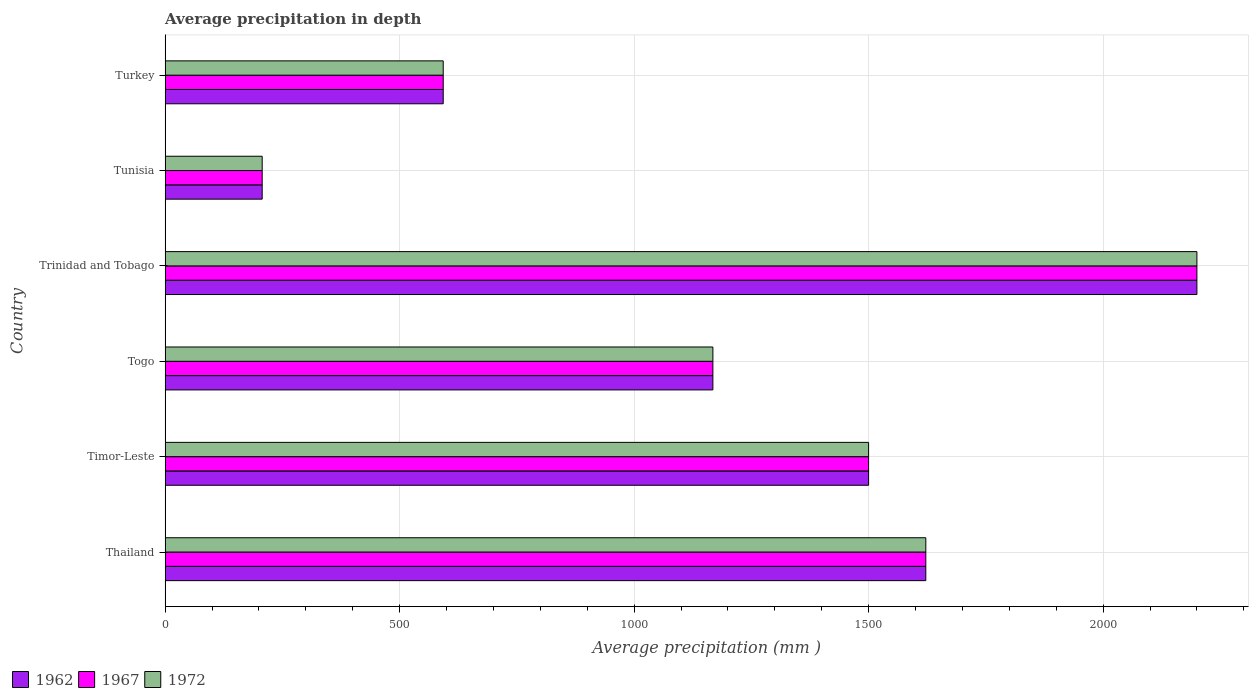How many different coloured bars are there?
Make the answer very short. 3. Are the number of bars on each tick of the Y-axis equal?
Your response must be concise. Yes. How many bars are there on the 5th tick from the top?
Keep it short and to the point. 3. What is the label of the 5th group of bars from the top?
Provide a short and direct response. Timor-Leste. In how many cases, is the number of bars for a given country not equal to the number of legend labels?
Ensure brevity in your answer.  0. What is the average precipitation in 1967 in Thailand?
Make the answer very short. 1622. Across all countries, what is the maximum average precipitation in 1972?
Offer a terse response. 2200. Across all countries, what is the minimum average precipitation in 1972?
Keep it short and to the point. 207. In which country was the average precipitation in 1962 maximum?
Offer a terse response. Trinidad and Tobago. In which country was the average precipitation in 1972 minimum?
Offer a very short reply. Tunisia. What is the total average precipitation in 1967 in the graph?
Your answer should be compact. 7290. What is the difference between the average precipitation in 1967 in Timor-Leste and that in Trinidad and Tobago?
Provide a succinct answer. -700. What is the difference between the average precipitation in 1972 in Thailand and the average precipitation in 1962 in Turkey?
Provide a succinct answer. 1029. What is the average average precipitation in 1967 per country?
Your response must be concise. 1215. What is the difference between the average precipitation in 1967 and average precipitation in 1972 in Togo?
Ensure brevity in your answer.  0. What is the ratio of the average precipitation in 1972 in Timor-Leste to that in Turkey?
Offer a very short reply. 2.53. Is the average precipitation in 1962 in Thailand less than that in Tunisia?
Give a very brief answer. No. Is the difference between the average precipitation in 1967 in Thailand and Trinidad and Tobago greater than the difference between the average precipitation in 1972 in Thailand and Trinidad and Tobago?
Ensure brevity in your answer.  No. What is the difference between the highest and the second highest average precipitation in 1967?
Your answer should be compact. 578. What is the difference between the highest and the lowest average precipitation in 1967?
Your answer should be very brief. 1993. What does the 3rd bar from the bottom in Thailand represents?
Your response must be concise. 1972. Is it the case that in every country, the sum of the average precipitation in 1962 and average precipitation in 1967 is greater than the average precipitation in 1972?
Provide a succinct answer. Yes. How many bars are there?
Your answer should be very brief. 18. Are all the bars in the graph horizontal?
Keep it short and to the point. Yes. What is the difference between two consecutive major ticks on the X-axis?
Offer a terse response. 500. Where does the legend appear in the graph?
Ensure brevity in your answer.  Bottom left. How many legend labels are there?
Make the answer very short. 3. What is the title of the graph?
Give a very brief answer. Average precipitation in depth. Does "1998" appear as one of the legend labels in the graph?
Your response must be concise. No. What is the label or title of the X-axis?
Provide a succinct answer. Average precipitation (mm ). What is the Average precipitation (mm ) of 1962 in Thailand?
Offer a terse response. 1622. What is the Average precipitation (mm ) in 1967 in Thailand?
Offer a very short reply. 1622. What is the Average precipitation (mm ) in 1972 in Thailand?
Provide a succinct answer. 1622. What is the Average precipitation (mm ) of 1962 in Timor-Leste?
Provide a succinct answer. 1500. What is the Average precipitation (mm ) in 1967 in Timor-Leste?
Make the answer very short. 1500. What is the Average precipitation (mm ) of 1972 in Timor-Leste?
Your response must be concise. 1500. What is the Average precipitation (mm ) in 1962 in Togo?
Provide a succinct answer. 1168. What is the Average precipitation (mm ) in 1967 in Togo?
Keep it short and to the point. 1168. What is the Average precipitation (mm ) in 1972 in Togo?
Provide a short and direct response. 1168. What is the Average precipitation (mm ) of 1962 in Trinidad and Tobago?
Offer a very short reply. 2200. What is the Average precipitation (mm ) of 1967 in Trinidad and Tobago?
Give a very brief answer. 2200. What is the Average precipitation (mm ) of 1972 in Trinidad and Tobago?
Your response must be concise. 2200. What is the Average precipitation (mm ) in 1962 in Tunisia?
Ensure brevity in your answer.  207. What is the Average precipitation (mm ) of 1967 in Tunisia?
Your answer should be very brief. 207. What is the Average precipitation (mm ) of 1972 in Tunisia?
Your answer should be compact. 207. What is the Average precipitation (mm ) of 1962 in Turkey?
Your response must be concise. 593. What is the Average precipitation (mm ) in 1967 in Turkey?
Ensure brevity in your answer.  593. What is the Average precipitation (mm ) of 1972 in Turkey?
Your answer should be very brief. 593. Across all countries, what is the maximum Average precipitation (mm ) of 1962?
Your answer should be compact. 2200. Across all countries, what is the maximum Average precipitation (mm ) of 1967?
Give a very brief answer. 2200. Across all countries, what is the maximum Average precipitation (mm ) in 1972?
Provide a succinct answer. 2200. Across all countries, what is the minimum Average precipitation (mm ) of 1962?
Provide a succinct answer. 207. Across all countries, what is the minimum Average precipitation (mm ) of 1967?
Your answer should be very brief. 207. Across all countries, what is the minimum Average precipitation (mm ) of 1972?
Provide a succinct answer. 207. What is the total Average precipitation (mm ) in 1962 in the graph?
Offer a terse response. 7290. What is the total Average precipitation (mm ) in 1967 in the graph?
Your response must be concise. 7290. What is the total Average precipitation (mm ) in 1972 in the graph?
Keep it short and to the point. 7290. What is the difference between the Average precipitation (mm ) of 1962 in Thailand and that in Timor-Leste?
Keep it short and to the point. 122. What is the difference between the Average precipitation (mm ) in 1967 in Thailand and that in Timor-Leste?
Your response must be concise. 122. What is the difference between the Average precipitation (mm ) of 1972 in Thailand and that in Timor-Leste?
Provide a short and direct response. 122. What is the difference between the Average precipitation (mm ) of 1962 in Thailand and that in Togo?
Give a very brief answer. 454. What is the difference between the Average precipitation (mm ) of 1967 in Thailand and that in Togo?
Offer a terse response. 454. What is the difference between the Average precipitation (mm ) in 1972 in Thailand and that in Togo?
Offer a terse response. 454. What is the difference between the Average precipitation (mm ) of 1962 in Thailand and that in Trinidad and Tobago?
Keep it short and to the point. -578. What is the difference between the Average precipitation (mm ) in 1967 in Thailand and that in Trinidad and Tobago?
Provide a short and direct response. -578. What is the difference between the Average precipitation (mm ) of 1972 in Thailand and that in Trinidad and Tobago?
Provide a short and direct response. -578. What is the difference between the Average precipitation (mm ) in 1962 in Thailand and that in Tunisia?
Your response must be concise. 1415. What is the difference between the Average precipitation (mm ) of 1967 in Thailand and that in Tunisia?
Offer a very short reply. 1415. What is the difference between the Average precipitation (mm ) of 1972 in Thailand and that in Tunisia?
Provide a succinct answer. 1415. What is the difference between the Average precipitation (mm ) of 1962 in Thailand and that in Turkey?
Make the answer very short. 1029. What is the difference between the Average precipitation (mm ) in 1967 in Thailand and that in Turkey?
Ensure brevity in your answer.  1029. What is the difference between the Average precipitation (mm ) of 1972 in Thailand and that in Turkey?
Your answer should be very brief. 1029. What is the difference between the Average precipitation (mm ) of 1962 in Timor-Leste and that in Togo?
Offer a very short reply. 332. What is the difference between the Average precipitation (mm ) of 1967 in Timor-Leste and that in Togo?
Your response must be concise. 332. What is the difference between the Average precipitation (mm ) in 1972 in Timor-Leste and that in Togo?
Ensure brevity in your answer.  332. What is the difference between the Average precipitation (mm ) in 1962 in Timor-Leste and that in Trinidad and Tobago?
Ensure brevity in your answer.  -700. What is the difference between the Average precipitation (mm ) of 1967 in Timor-Leste and that in Trinidad and Tobago?
Give a very brief answer. -700. What is the difference between the Average precipitation (mm ) of 1972 in Timor-Leste and that in Trinidad and Tobago?
Your answer should be compact. -700. What is the difference between the Average precipitation (mm ) in 1962 in Timor-Leste and that in Tunisia?
Make the answer very short. 1293. What is the difference between the Average precipitation (mm ) in 1967 in Timor-Leste and that in Tunisia?
Your answer should be very brief. 1293. What is the difference between the Average precipitation (mm ) of 1972 in Timor-Leste and that in Tunisia?
Ensure brevity in your answer.  1293. What is the difference between the Average precipitation (mm ) of 1962 in Timor-Leste and that in Turkey?
Provide a short and direct response. 907. What is the difference between the Average precipitation (mm ) in 1967 in Timor-Leste and that in Turkey?
Offer a terse response. 907. What is the difference between the Average precipitation (mm ) in 1972 in Timor-Leste and that in Turkey?
Your response must be concise. 907. What is the difference between the Average precipitation (mm ) of 1962 in Togo and that in Trinidad and Tobago?
Your answer should be compact. -1032. What is the difference between the Average precipitation (mm ) of 1967 in Togo and that in Trinidad and Tobago?
Your response must be concise. -1032. What is the difference between the Average precipitation (mm ) of 1972 in Togo and that in Trinidad and Tobago?
Provide a short and direct response. -1032. What is the difference between the Average precipitation (mm ) in 1962 in Togo and that in Tunisia?
Offer a terse response. 961. What is the difference between the Average precipitation (mm ) in 1967 in Togo and that in Tunisia?
Your answer should be very brief. 961. What is the difference between the Average precipitation (mm ) of 1972 in Togo and that in Tunisia?
Your answer should be compact. 961. What is the difference between the Average precipitation (mm ) of 1962 in Togo and that in Turkey?
Provide a succinct answer. 575. What is the difference between the Average precipitation (mm ) in 1967 in Togo and that in Turkey?
Offer a very short reply. 575. What is the difference between the Average precipitation (mm ) in 1972 in Togo and that in Turkey?
Your response must be concise. 575. What is the difference between the Average precipitation (mm ) of 1962 in Trinidad and Tobago and that in Tunisia?
Keep it short and to the point. 1993. What is the difference between the Average precipitation (mm ) of 1967 in Trinidad and Tobago and that in Tunisia?
Your answer should be compact. 1993. What is the difference between the Average precipitation (mm ) in 1972 in Trinidad and Tobago and that in Tunisia?
Give a very brief answer. 1993. What is the difference between the Average precipitation (mm ) in 1962 in Trinidad and Tobago and that in Turkey?
Offer a very short reply. 1607. What is the difference between the Average precipitation (mm ) of 1967 in Trinidad and Tobago and that in Turkey?
Your answer should be compact. 1607. What is the difference between the Average precipitation (mm ) in 1972 in Trinidad and Tobago and that in Turkey?
Keep it short and to the point. 1607. What is the difference between the Average precipitation (mm ) of 1962 in Tunisia and that in Turkey?
Give a very brief answer. -386. What is the difference between the Average precipitation (mm ) in 1967 in Tunisia and that in Turkey?
Offer a very short reply. -386. What is the difference between the Average precipitation (mm ) in 1972 in Tunisia and that in Turkey?
Provide a short and direct response. -386. What is the difference between the Average precipitation (mm ) in 1962 in Thailand and the Average precipitation (mm ) in 1967 in Timor-Leste?
Give a very brief answer. 122. What is the difference between the Average precipitation (mm ) in 1962 in Thailand and the Average precipitation (mm ) in 1972 in Timor-Leste?
Your answer should be compact. 122. What is the difference between the Average precipitation (mm ) of 1967 in Thailand and the Average precipitation (mm ) of 1972 in Timor-Leste?
Your answer should be very brief. 122. What is the difference between the Average precipitation (mm ) of 1962 in Thailand and the Average precipitation (mm ) of 1967 in Togo?
Your answer should be compact. 454. What is the difference between the Average precipitation (mm ) in 1962 in Thailand and the Average precipitation (mm ) in 1972 in Togo?
Keep it short and to the point. 454. What is the difference between the Average precipitation (mm ) of 1967 in Thailand and the Average precipitation (mm ) of 1972 in Togo?
Make the answer very short. 454. What is the difference between the Average precipitation (mm ) of 1962 in Thailand and the Average precipitation (mm ) of 1967 in Trinidad and Tobago?
Your answer should be compact. -578. What is the difference between the Average precipitation (mm ) in 1962 in Thailand and the Average precipitation (mm ) in 1972 in Trinidad and Tobago?
Keep it short and to the point. -578. What is the difference between the Average precipitation (mm ) of 1967 in Thailand and the Average precipitation (mm ) of 1972 in Trinidad and Tobago?
Provide a short and direct response. -578. What is the difference between the Average precipitation (mm ) in 1962 in Thailand and the Average precipitation (mm ) in 1967 in Tunisia?
Offer a terse response. 1415. What is the difference between the Average precipitation (mm ) in 1962 in Thailand and the Average precipitation (mm ) in 1972 in Tunisia?
Your response must be concise. 1415. What is the difference between the Average precipitation (mm ) of 1967 in Thailand and the Average precipitation (mm ) of 1972 in Tunisia?
Your answer should be very brief. 1415. What is the difference between the Average precipitation (mm ) of 1962 in Thailand and the Average precipitation (mm ) of 1967 in Turkey?
Your response must be concise. 1029. What is the difference between the Average precipitation (mm ) of 1962 in Thailand and the Average precipitation (mm ) of 1972 in Turkey?
Ensure brevity in your answer.  1029. What is the difference between the Average precipitation (mm ) in 1967 in Thailand and the Average precipitation (mm ) in 1972 in Turkey?
Provide a succinct answer. 1029. What is the difference between the Average precipitation (mm ) of 1962 in Timor-Leste and the Average precipitation (mm ) of 1967 in Togo?
Make the answer very short. 332. What is the difference between the Average precipitation (mm ) in 1962 in Timor-Leste and the Average precipitation (mm ) in 1972 in Togo?
Your answer should be very brief. 332. What is the difference between the Average precipitation (mm ) of 1967 in Timor-Leste and the Average precipitation (mm ) of 1972 in Togo?
Keep it short and to the point. 332. What is the difference between the Average precipitation (mm ) of 1962 in Timor-Leste and the Average precipitation (mm ) of 1967 in Trinidad and Tobago?
Offer a terse response. -700. What is the difference between the Average precipitation (mm ) in 1962 in Timor-Leste and the Average precipitation (mm ) in 1972 in Trinidad and Tobago?
Your answer should be very brief. -700. What is the difference between the Average precipitation (mm ) in 1967 in Timor-Leste and the Average precipitation (mm ) in 1972 in Trinidad and Tobago?
Make the answer very short. -700. What is the difference between the Average precipitation (mm ) in 1962 in Timor-Leste and the Average precipitation (mm ) in 1967 in Tunisia?
Provide a short and direct response. 1293. What is the difference between the Average precipitation (mm ) of 1962 in Timor-Leste and the Average precipitation (mm ) of 1972 in Tunisia?
Give a very brief answer. 1293. What is the difference between the Average precipitation (mm ) in 1967 in Timor-Leste and the Average precipitation (mm ) in 1972 in Tunisia?
Keep it short and to the point. 1293. What is the difference between the Average precipitation (mm ) of 1962 in Timor-Leste and the Average precipitation (mm ) of 1967 in Turkey?
Keep it short and to the point. 907. What is the difference between the Average precipitation (mm ) of 1962 in Timor-Leste and the Average precipitation (mm ) of 1972 in Turkey?
Offer a very short reply. 907. What is the difference between the Average precipitation (mm ) of 1967 in Timor-Leste and the Average precipitation (mm ) of 1972 in Turkey?
Make the answer very short. 907. What is the difference between the Average precipitation (mm ) of 1962 in Togo and the Average precipitation (mm ) of 1967 in Trinidad and Tobago?
Your response must be concise. -1032. What is the difference between the Average precipitation (mm ) in 1962 in Togo and the Average precipitation (mm ) in 1972 in Trinidad and Tobago?
Your answer should be compact. -1032. What is the difference between the Average precipitation (mm ) in 1967 in Togo and the Average precipitation (mm ) in 1972 in Trinidad and Tobago?
Offer a very short reply. -1032. What is the difference between the Average precipitation (mm ) in 1962 in Togo and the Average precipitation (mm ) in 1967 in Tunisia?
Make the answer very short. 961. What is the difference between the Average precipitation (mm ) of 1962 in Togo and the Average precipitation (mm ) of 1972 in Tunisia?
Make the answer very short. 961. What is the difference between the Average precipitation (mm ) of 1967 in Togo and the Average precipitation (mm ) of 1972 in Tunisia?
Offer a very short reply. 961. What is the difference between the Average precipitation (mm ) of 1962 in Togo and the Average precipitation (mm ) of 1967 in Turkey?
Your answer should be very brief. 575. What is the difference between the Average precipitation (mm ) of 1962 in Togo and the Average precipitation (mm ) of 1972 in Turkey?
Offer a terse response. 575. What is the difference between the Average precipitation (mm ) in 1967 in Togo and the Average precipitation (mm ) in 1972 in Turkey?
Provide a succinct answer. 575. What is the difference between the Average precipitation (mm ) of 1962 in Trinidad and Tobago and the Average precipitation (mm ) of 1967 in Tunisia?
Keep it short and to the point. 1993. What is the difference between the Average precipitation (mm ) of 1962 in Trinidad and Tobago and the Average precipitation (mm ) of 1972 in Tunisia?
Provide a short and direct response. 1993. What is the difference between the Average precipitation (mm ) of 1967 in Trinidad and Tobago and the Average precipitation (mm ) of 1972 in Tunisia?
Provide a short and direct response. 1993. What is the difference between the Average precipitation (mm ) in 1962 in Trinidad and Tobago and the Average precipitation (mm ) in 1967 in Turkey?
Give a very brief answer. 1607. What is the difference between the Average precipitation (mm ) of 1962 in Trinidad and Tobago and the Average precipitation (mm ) of 1972 in Turkey?
Your answer should be very brief. 1607. What is the difference between the Average precipitation (mm ) of 1967 in Trinidad and Tobago and the Average precipitation (mm ) of 1972 in Turkey?
Your answer should be compact. 1607. What is the difference between the Average precipitation (mm ) in 1962 in Tunisia and the Average precipitation (mm ) in 1967 in Turkey?
Your answer should be very brief. -386. What is the difference between the Average precipitation (mm ) of 1962 in Tunisia and the Average precipitation (mm ) of 1972 in Turkey?
Your answer should be compact. -386. What is the difference between the Average precipitation (mm ) of 1967 in Tunisia and the Average precipitation (mm ) of 1972 in Turkey?
Keep it short and to the point. -386. What is the average Average precipitation (mm ) in 1962 per country?
Make the answer very short. 1215. What is the average Average precipitation (mm ) in 1967 per country?
Your answer should be compact. 1215. What is the average Average precipitation (mm ) in 1972 per country?
Your response must be concise. 1215. What is the difference between the Average precipitation (mm ) of 1962 and Average precipitation (mm ) of 1972 in Thailand?
Ensure brevity in your answer.  0. What is the difference between the Average precipitation (mm ) of 1967 and Average precipitation (mm ) of 1972 in Thailand?
Your answer should be very brief. 0. What is the difference between the Average precipitation (mm ) in 1962 and Average precipitation (mm ) in 1972 in Timor-Leste?
Offer a very short reply. 0. What is the difference between the Average precipitation (mm ) of 1967 and Average precipitation (mm ) of 1972 in Timor-Leste?
Your answer should be very brief. 0. What is the difference between the Average precipitation (mm ) of 1962 and Average precipitation (mm ) of 1967 in Trinidad and Tobago?
Offer a terse response. 0. What is the difference between the Average precipitation (mm ) in 1962 and Average precipitation (mm ) in 1972 in Trinidad and Tobago?
Your answer should be very brief. 0. What is the difference between the Average precipitation (mm ) in 1962 and Average precipitation (mm ) in 1967 in Tunisia?
Provide a succinct answer. 0. What is the difference between the Average precipitation (mm ) in 1967 and Average precipitation (mm ) in 1972 in Tunisia?
Your answer should be compact. 0. What is the difference between the Average precipitation (mm ) of 1962 and Average precipitation (mm ) of 1972 in Turkey?
Keep it short and to the point. 0. What is the ratio of the Average precipitation (mm ) in 1962 in Thailand to that in Timor-Leste?
Keep it short and to the point. 1.08. What is the ratio of the Average precipitation (mm ) of 1967 in Thailand to that in Timor-Leste?
Keep it short and to the point. 1.08. What is the ratio of the Average precipitation (mm ) of 1972 in Thailand to that in Timor-Leste?
Provide a succinct answer. 1.08. What is the ratio of the Average precipitation (mm ) in 1962 in Thailand to that in Togo?
Keep it short and to the point. 1.39. What is the ratio of the Average precipitation (mm ) in 1967 in Thailand to that in Togo?
Your answer should be compact. 1.39. What is the ratio of the Average precipitation (mm ) of 1972 in Thailand to that in Togo?
Make the answer very short. 1.39. What is the ratio of the Average precipitation (mm ) in 1962 in Thailand to that in Trinidad and Tobago?
Your answer should be very brief. 0.74. What is the ratio of the Average precipitation (mm ) of 1967 in Thailand to that in Trinidad and Tobago?
Make the answer very short. 0.74. What is the ratio of the Average precipitation (mm ) of 1972 in Thailand to that in Trinidad and Tobago?
Your response must be concise. 0.74. What is the ratio of the Average precipitation (mm ) in 1962 in Thailand to that in Tunisia?
Your answer should be very brief. 7.84. What is the ratio of the Average precipitation (mm ) of 1967 in Thailand to that in Tunisia?
Ensure brevity in your answer.  7.84. What is the ratio of the Average precipitation (mm ) of 1972 in Thailand to that in Tunisia?
Your response must be concise. 7.84. What is the ratio of the Average precipitation (mm ) in 1962 in Thailand to that in Turkey?
Provide a short and direct response. 2.74. What is the ratio of the Average precipitation (mm ) in 1967 in Thailand to that in Turkey?
Provide a succinct answer. 2.74. What is the ratio of the Average precipitation (mm ) of 1972 in Thailand to that in Turkey?
Offer a very short reply. 2.74. What is the ratio of the Average precipitation (mm ) in 1962 in Timor-Leste to that in Togo?
Provide a short and direct response. 1.28. What is the ratio of the Average precipitation (mm ) in 1967 in Timor-Leste to that in Togo?
Your answer should be compact. 1.28. What is the ratio of the Average precipitation (mm ) of 1972 in Timor-Leste to that in Togo?
Your answer should be very brief. 1.28. What is the ratio of the Average precipitation (mm ) in 1962 in Timor-Leste to that in Trinidad and Tobago?
Make the answer very short. 0.68. What is the ratio of the Average precipitation (mm ) in 1967 in Timor-Leste to that in Trinidad and Tobago?
Your answer should be very brief. 0.68. What is the ratio of the Average precipitation (mm ) in 1972 in Timor-Leste to that in Trinidad and Tobago?
Give a very brief answer. 0.68. What is the ratio of the Average precipitation (mm ) of 1962 in Timor-Leste to that in Tunisia?
Your response must be concise. 7.25. What is the ratio of the Average precipitation (mm ) in 1967 in Timor-Leste to that in Tunisia?
Your answer should be compact. 7.25. What is the ratio of the Average precipitation (mm ) of 1972 in Timor-Leste to that in Tunisia?
Offer a very short reply. 7.25. What is the ratio of the Average precipitation (mm ) of 1962 in Timor-Leste to that in Turkey?
Your answer should be very brief. 2.53. What is the ratio of the Average precipitation (mm ) in 1967 in Timor-Leste to that in Turkey?
Make the answer very short. 2.53. What is the ratio of the Average precipitation (mm ) in 1972 in Timor-Leste to that in Turkey?
Your response must be concise. 2.53. What is the ratio of the Average precipitation (mm ) in 1962 in Togo to that in Trinidad and Tobago?
Provide a short and direct response. 0.53. What is the ratio of the Average precipitation (mm ) of 1967 in Togo to that in Trinidad and Tobago?
Your response must be concise. 0.53. What is the ratio of the Average precipitation (mm ) in 1972 in Togo to that in Trinidad and Tobago?
Provide a succinct answer. 0.53. What is the ratio of the Average precipitation (mm ) of 1962 in Togo to that in Tunisia?
Provide a short and direct response. 5.64. What is the ratio of the Average precipitation (mm ) in 1967 in Togo to that in Tunisia?
Offer a terse response. 5.64. What is the ratio of the Average precipitation (mm ) of 1972 in Togo to that in Tunisia?
Offer a terse response. 5.64. What is the ratio of the Average precipitation (mm ) in 1962 in Togo to that in Turkey?
Your answer should be compact. 1.97. What is the ratio of the Average precipitation (mm ) of 1967 in Togo to that in Turkey?
Your answer should be compact. 1.97. What is the ratio of the Average precipitation (mm ) in 1972 in Togo to that in Turkey?
Give a very brief answer. 1.97. What is the ratio of the Average precipitation (mm ) of 1962 in Trinidad and Tobago to that in Tunisia?
Your answer should be compact. 10.63. What is the ratio of the Average precipitation (mm ) in 1967 in Trinidad and Tobago to that in Tunisia?
Ensure brevity in your answer.  10.63. What is the ratio of the Average precipitation (mm ) of 1972 in Trinidad and Tobago to that in Tunisia?
Your response must be concise. 10.63. What is the ratio of the Average precipitation (mm ) in 1962 in Trinidad and Tobago to that in Turkey?
Offer a terse response. 3.71. What is the ratio of the Average precipitation (mm ) of 1967 in Trinidad and Tobago to that in Turkey?
Offer a very short reply. 3.71. What is the ratio of the Average precipitation (mm ) in 1972 in Trinidad and Tobago to that in Turkey?
Keep it short and to the point. 3.71. What is the ratio of the Average precipitation (mm ) of 1962 in Tunisia to that in Turkey?
Your response must be concise. 0.35. What is the ratio of the Average precipitation (mm ) in 1967 in Tunisia to that in Turkey?
Ensure brevity in your answer.  0.35. What is the ratio of the Average precipitation (mm ) of 1972 in Tunisia to that in Turkey?
Provide a short and direct response. 0.35. What is the difference between the highest and the second highest Average precipitation (mm ) in 1962?
Offer a terse response. 578. What is the difference between the highest and the second highest Average precipitation (mm ) in 1967?
Provide a succinct answer. 578. What is the difference between the highest and the second highest Average precipitation (mm ) of 1972?
Make the answer very short. 578. What is the difference between the highest and the lowest Average precipitation (mm ) of 1962?
Offer a very short reply. 1993. What is the difference between the highest and the lowest Average precipitation (mm ) in 1967?
Offer a very short reply. 1993. What is the difference between the highest and the lowest Average precipitation (mm ) of 1972?
Make the answer very short. 1993. 